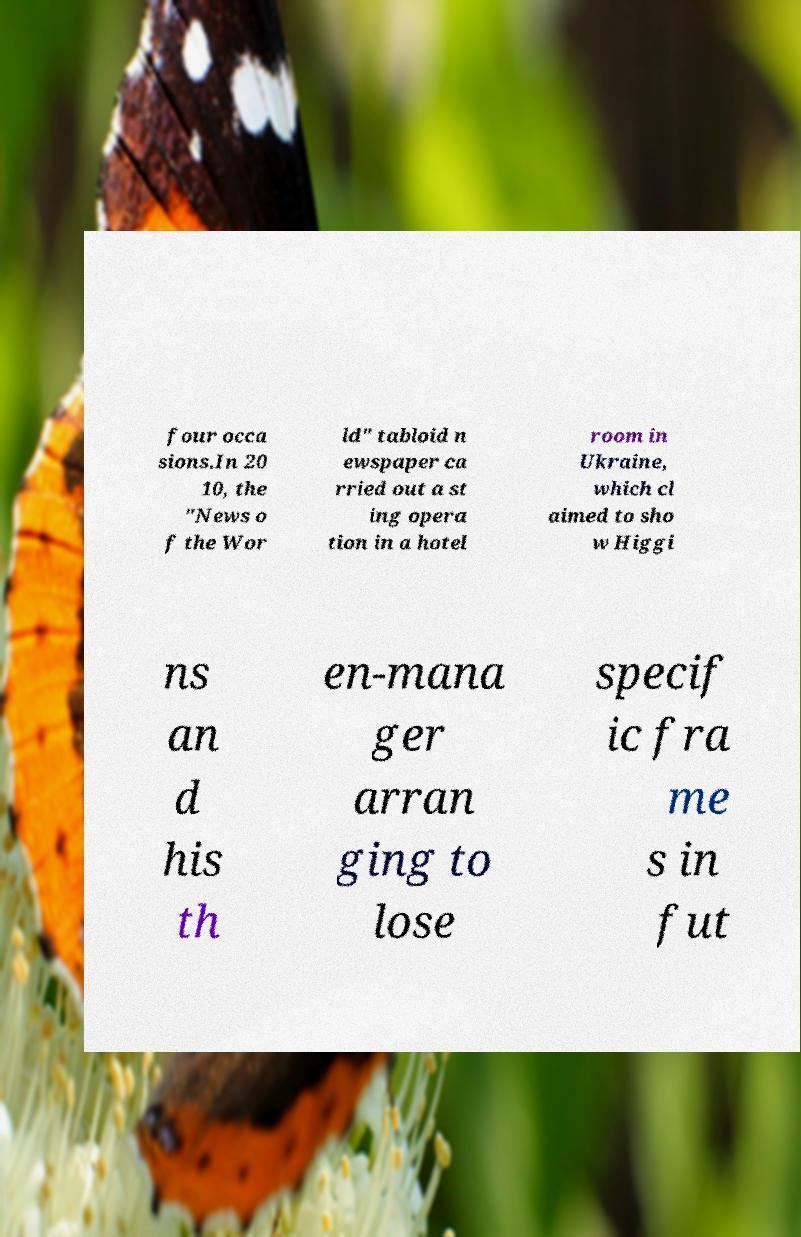Could you extract and type out the text from this image? four occa sions.In 20 10, the "News o f the Wor ld" tabloid n ewspaper ca rried out a st ing opera tion in a hotel room in Ukraine, which cl aimed to sho w Higgi ns an d his th en-mana ger arran ging to lose specif ic fra me s in fut 